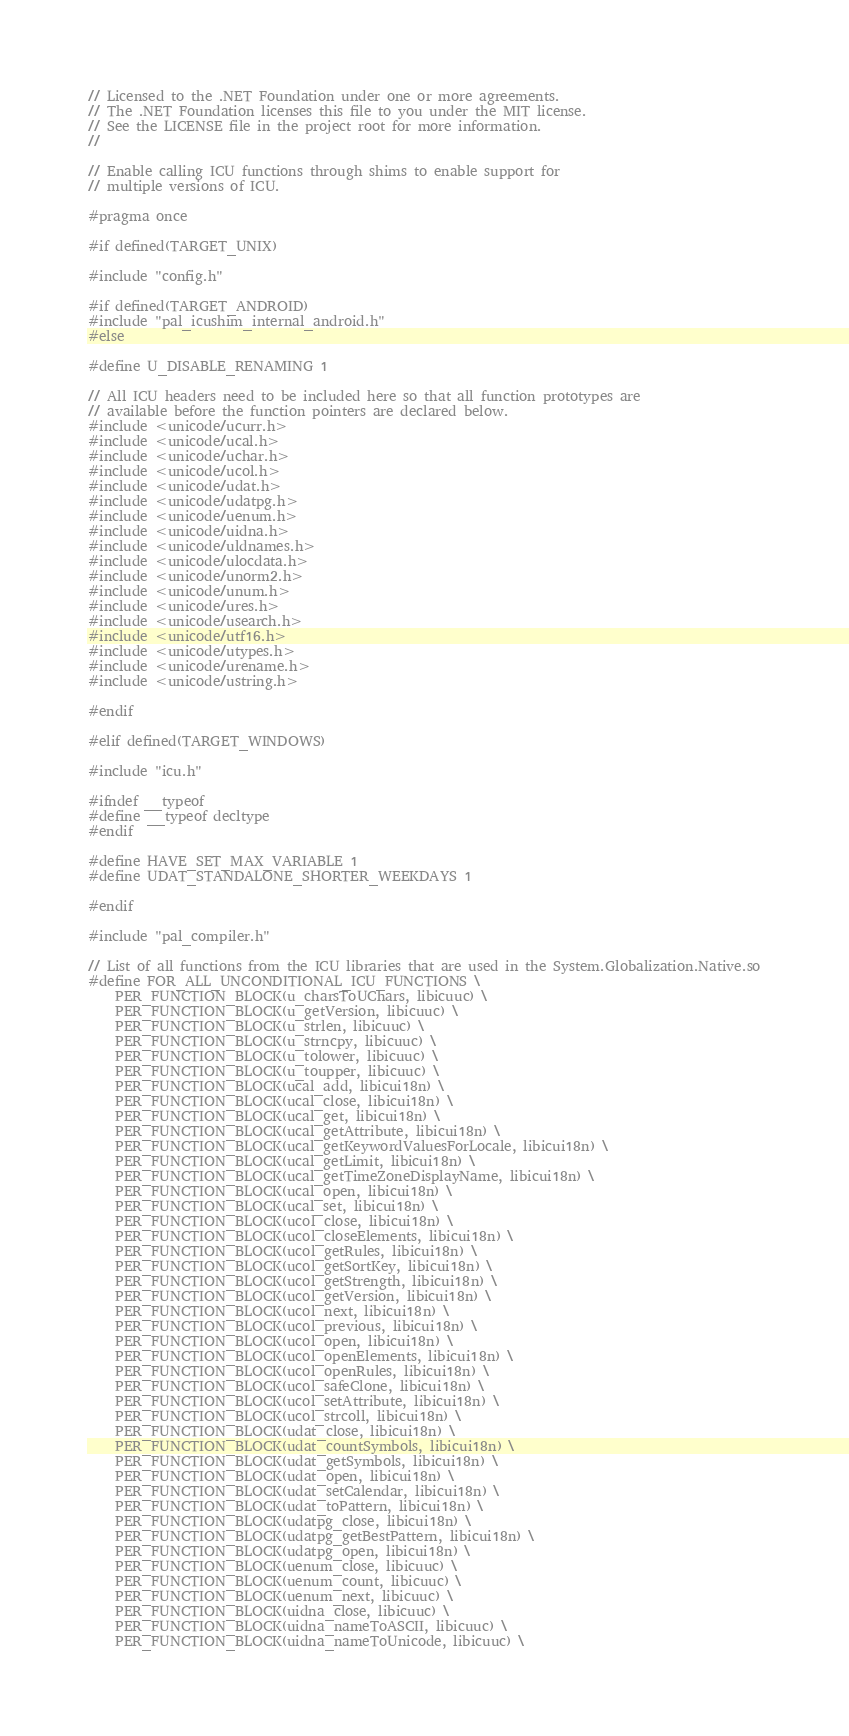<code> <loc_0><loc_0><loc_500><loc_500><_C_>// Licensed to the .NET Foundation under one or more agreements.
// The .NET Foundation licenses this file to you under the MIT license.
// See the LICENSE file in the project root for more information.
//

// Enable calling ICU functions through shims to enable support for
// multiple versions of ICU.

#pragma once

#if defined(TARGET_UNIX)

#include "config.h"

#if defined(TARGET_ANDROID)
#include "pal_icushim_internal_android.h"
#else

#define U_DISABLE_RENAMING 1

// All ICU headers need to be included here so that all function prototypes are
// available before the function pointers are declared below.
#include <unicode/ucurr.h>
#include <unicode/ucal.h>
#include <unicode/uchar.h>
#include <unicode/ucol.h>
#include <unicode/udat.h>
#include <unicode/udatpg.h>
#include <unicode/uenum.h>
#include <unicode/uidna.h>
#include <unicode/uldnames.h>
#include <unicode/ulocdata.h>
#include <unicode/unorm2.h>
#include <unicode/unum.h>
#include <unicode/ures.h>
#include <unicode/usearch.h>
#include <unicode/utf16.h>
#include <unicode/utypes.h>
#include <unicode/urename.h>
#include <unicode/ustring.h>

#endif

#elif defined(TARGET_WINDOWS)

#include "icu.h"

#ifndef __typeof
#define __typeof decltype
#endif

#define HAVE_SET_MAX_VARIABLE 1
#define UDAT_STANDALONE_SHORTER_WEEKDAYS 1

#endif

#include "pal_compiler.h"

// List of all functions from the ICU libraries that are used in the System.Globalization.Native.so
#define FOR_ALL_UNCONDITIONAL_ICU_FUNCTIONS \
    PER_FUNCTION_BLOCK(u_charsToUChars, libicuuc) \
    PER_FUNCTION_BLOCK(u_getVersion, libicuuc) \
    PER_FUNCTION_BLOCK(u_strlen, libicuuc) \
    PER_FUNCTION_BLOCK(u_strncpy, libicuuc) \
    PER_FUNCTION_BLOCK(u_tolower, libicuuc) \
    PER_FUNCTION_BLOCK(u_toupper, libicuuc) \
    PER_FUNCTION_BLOCK(ucal_add, libicui18n) \
    PER_FUNCTION_BLOCK(ucal_close, libicui18n) \
    PER_FUNCTION_BLOCK(ucal_get, libicui18n) \
    PER_FUNCTION_BLOCK(ucal_getAttribute, libicui18n) \
    PER_FUNCTION_BLOCK(ucal_getKeywordValuesForLocale, libicui18n) \
    PER_FUNCTION_BLOCK(ucal_getLimit, libicui18n) \
    PER_FUNCTION_BLOCK(ucal_getTimeZoneDisplayName, libicui18n) \
    PER_FUNCTION_BLOCK(ucal_open, libicui18n) \
    PER_FUNCTION_BLOCK(ucal_set, libicui18n) \
    PER_FUNCTION_BLOCK(ucol_close, libicui18n) \
    PER_FUNCTION_BLOCK(ucol_closeElements, libicui18n) \
    PER_FUNCTION_BLOCK(ucol_getRules, libicui18n) \
    PER_FUNCTION_BLOCK(ucol_getSortKey, libicui18n) \
    PER_FUNCTION_BLOCK(ucol_getStrength, libicui18n) \
    PER_FUNCTION_BLOCK(ucol_getVersion, libicui18n) \
    PER_FUNCTION_BLOCK(ucol_next, libicui18n) \
    PER_FUNCTION_BLOCK(ucol_previous, libicui18n) \
    PER_FUNCTION_BLOCK(ucol_open, libicui18n) \
    PER_FUNCTION_BLOCK(ucol_openElements, libicui18n) \
    PER_FUNCTION_BLOCK(ucol_openRules, libicui18n) \
    PER_FUNCTION_BLOCK(ucol_safeClone, libicui18n) \
    PER_FUNCTION_BLOCK(ucol_setAttribute, libicui18n) \
    PER_FUNCTION_BLOCK(ucol_strcoll, libicui18n) \
    PER_FUNCTION_BLOCK(udat_close, libicui18n) \
    PER_FUNCTION_BLOCK(udat_countSymbols, libicui18n) \
    PER_FUNCTION_BLOCK(udat_getSymbols, libicui18n) \
    PER_FUNCTION_BLOCK(udat_open, libicui18n) \
    PER_FUNCTION_BLOCK(udat_setCalendar, libicui18n) \
    PER_FUNCTION_BLOCK(udat_toPattern, libicui18n) \
    PER_FUNCTION_BLOCK(udatpg_close, libicui18n) \
    PER_FUNCTION_BLOCK(udatpg_getBestPattern, libicui18n) \
    PER_FUNCTION_BLOCK(udatpg_open, libicui18n) \
    PER_FUNCTION_BLOCK(uenum_close, libicuuc) \
    PER_FUNCTION_BLOCK(uenum_count, libicuuc) \
    PER_FUNCTION_BLOCK(uenum_next, libicuuc) \
    PER_FUNCTION_BLOCK(uidna_close, libicuuc) \
    PER_FUNCTION_BLOCK(uidna_nameToASCII, libicuuc) \
    PER_FUNCTION_BLOCK(uidna_nameToUnicode, libicuuc) \</code> 